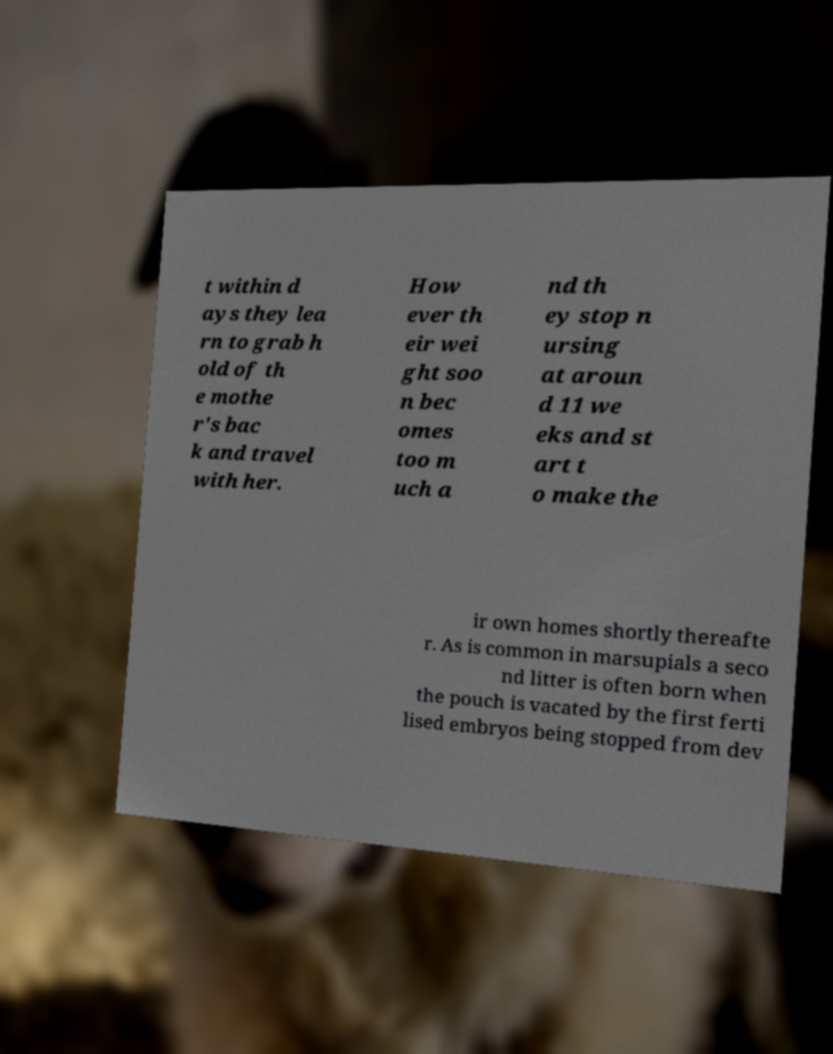Please read and relay the text visible in this image. What does it say? t within d ays they lea rn to grab h old of th e mothe r's bac k and travel with her. How ever th eir wei ght soo n bec omes too m uch a nd th ey stop n ursing at aroun d 11 we eks and st art t o make the ir own homes shortly thereafte r. As is common in marsupials a seco nd litter is often born when the pouch is vacated by the first ferti lised embryos being stopped from dev 